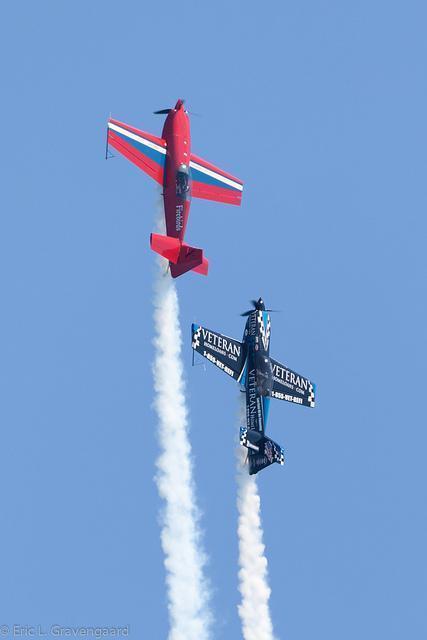How many planes are there?
Give a very brief answer. 2. How many airplanes are visible?
Give a very brief answer. 2. 